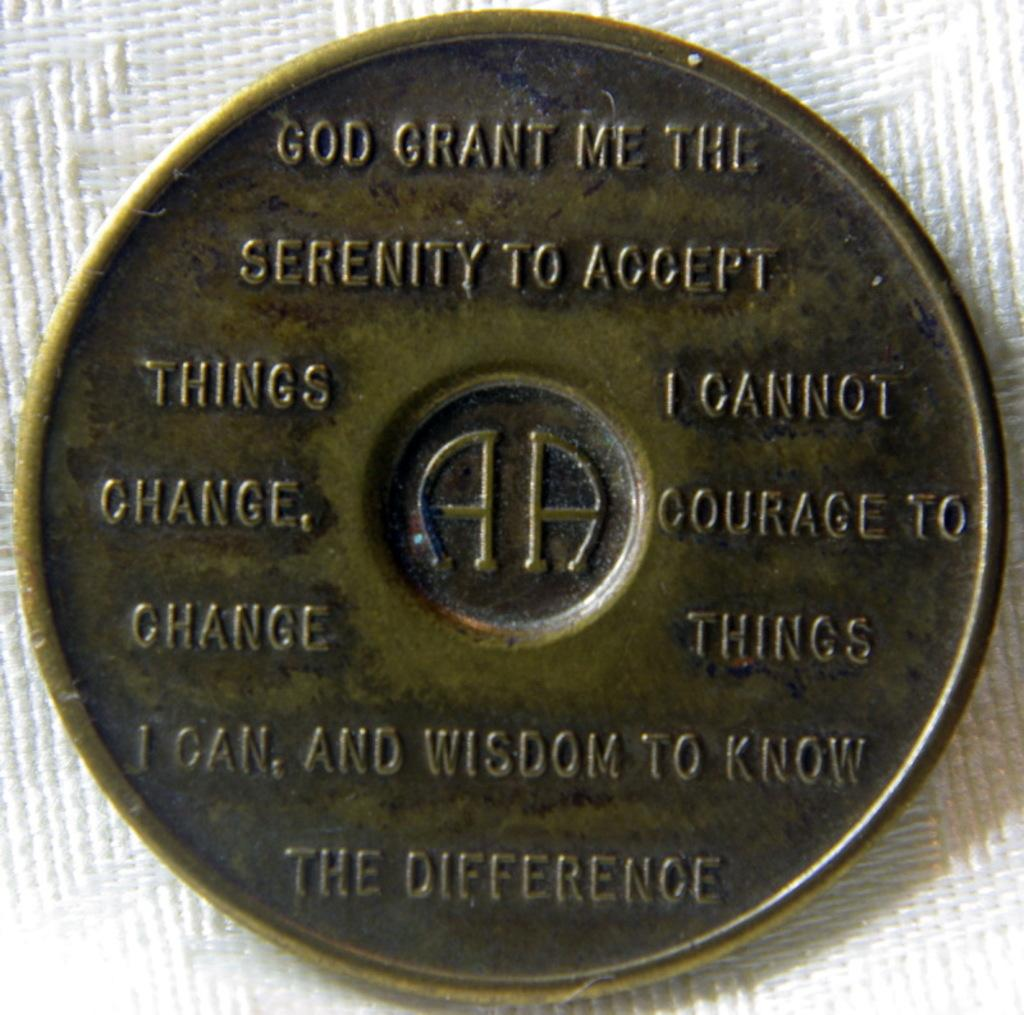<image>
Write a terse but informative summary of the picture. "God grant me the serenity to accept things I cannot change, courage to change things I can, and wisdom to know the difference" is etched onto this AA coin. 